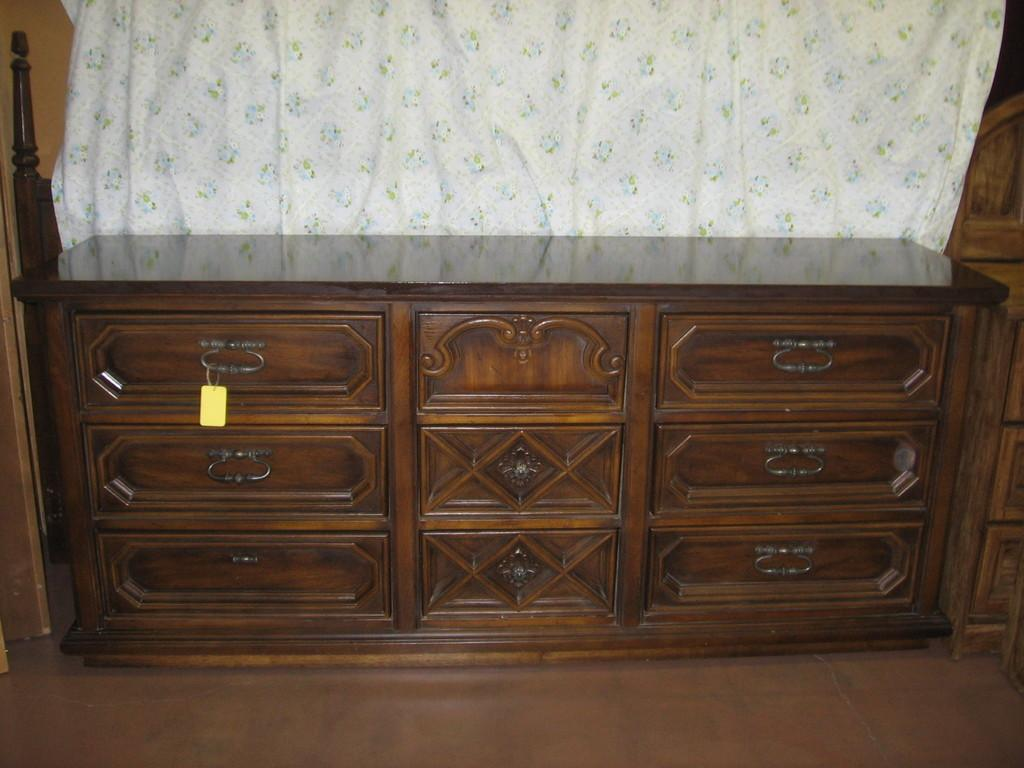What type of furniture is present in the image? There are drawers in the image. What type of window treatment is visible in the image? There is a curtain in the image. How many clocks are present in the image? There are no clocks visible in the image. What type of trade is being conducted in the image? There is no trade being conducted in the image; it only features drawers and a curtain. 